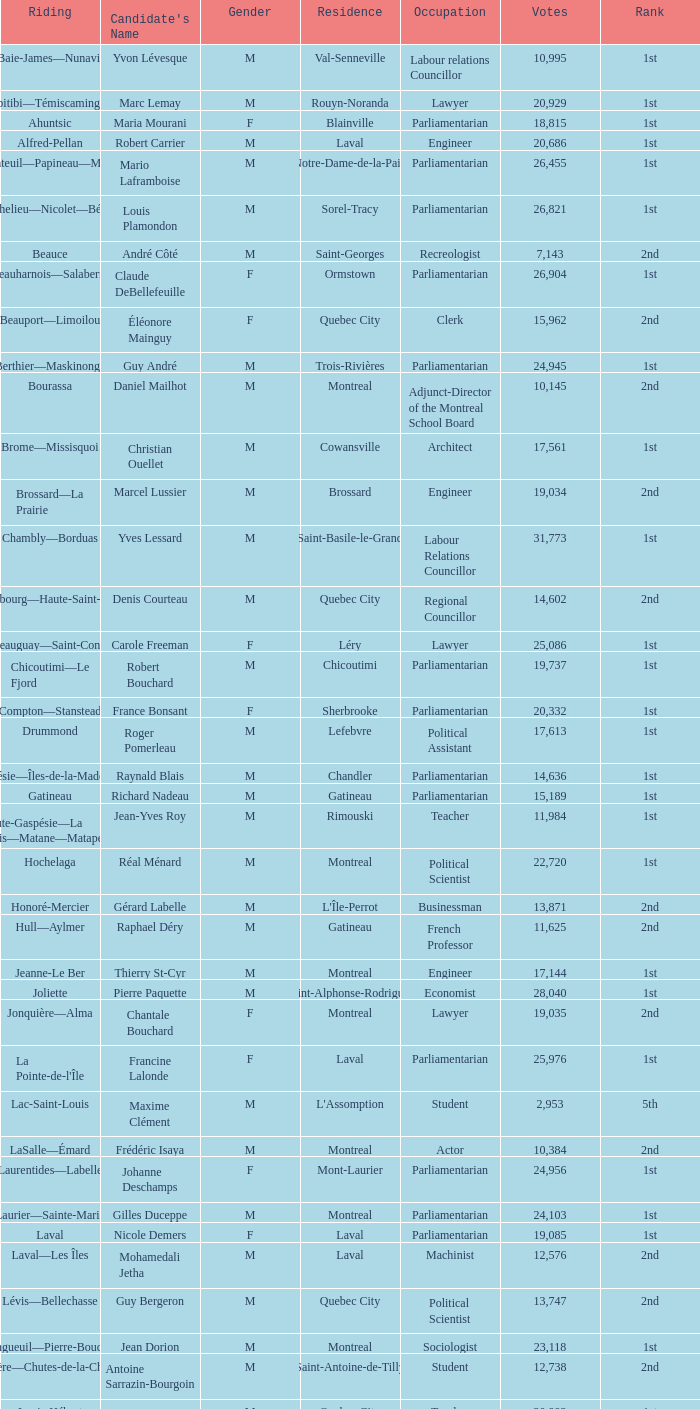What is the largest number of votes for the french professor? 11625.0. 